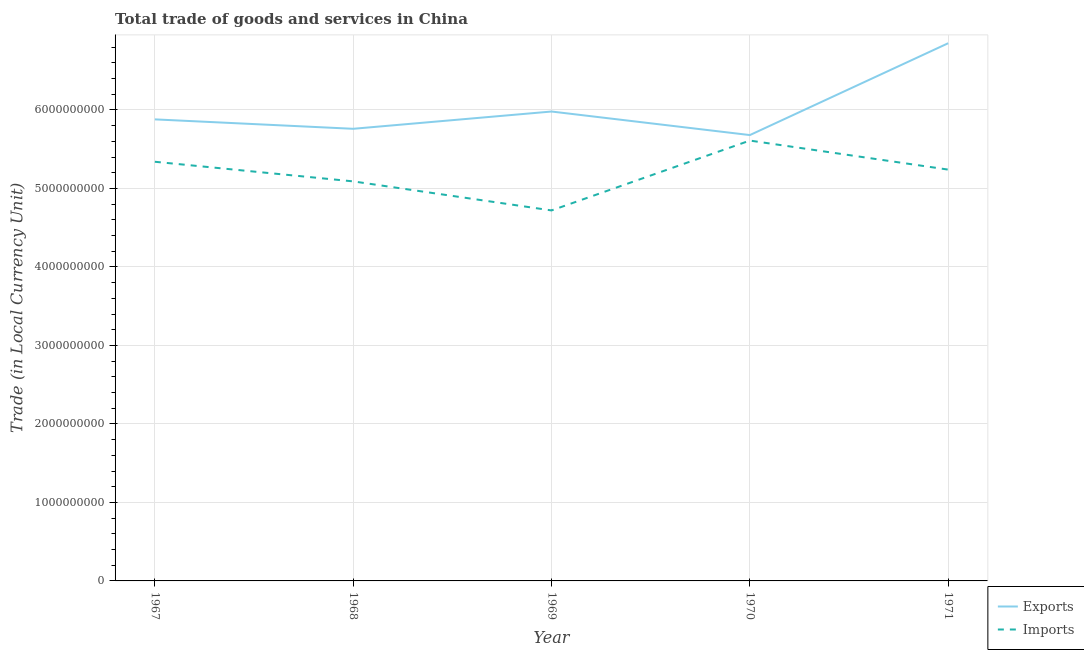How many different coloured lines are there?
Provide a short and direct response. 2. Is the number of lines equal to the number of legend labels?
Provide a short and direct response. Yes. What is the imports of goods and services in 1968?
Offer a terse response. 5.09e+09. Across all years, what is the maximum imports of goods and services?
Ensure brevity in your answer.  5.61e+09. Across all years, what is the minimum export of goods and services?
Keep it short and to the point. 5.68e+09. In which year was the imports of goods and services minimum?
Your answer should be very brief. 1969. What is the total export of goods and services in the graph?
Offer a very short reply. 3.02e+1. What is the difference between the export of goods and services in 1969 and that in 1971?
Keep it short and to the point. -8.70e+08. What is the difference between the imports of goods and services in 1971 and the export of goods and services in 1969?
Offer a very short reply. -7.40e+08. What is the average export of goods and services per year?
Provide a short and direct response. 6.03e+09. In the year 1969, what is the difference between the imports of goods and services and export of goods and services?
Offer a very short reply. -1.26e+09. What is the ratio of the imports of goods and services in 1970 to that in 1971?
Provide a short and direct response. 1.07. Is the export of goods and services in 1967 less than that in 1969?
Your answer should be compact. Yes. What is the difference between the highest and the second highest export of goods and services?
Your response must be concise. 8.70e+08. What is the difference between the highest and the lowest export of goods and services?
Keep it short and to the point. 1.17e+09. Does the export of goods and services monotonically increase over the years?
Ensure brevity in your answer.  No. Is the export of goods and services strictly greater than the imports of goods and services over the years?
Your answer should be compact. Yes. Is the imports of goods and services strictly less than the export of goods and services over the years?
Your answer should be compact. Yes. How many lines are there?
Ensure brevity in your answer.  2. How many years are there in the graph?
Your response must be concise. 5. What is the difference between two consecutive major ticks on the Y-axis?
Provide a short and direct response. 1.00e+09. Are the values on the major ticks of Y-axis written in scientific E-notation?
Offer a very short reply. No. How many legend labels are there?
Offer a terse response. 2. What is the title of the graph?
Your answer should be very brief. Total trade of goods and services in China. Does "Netherlands" appear as one of the legend labels in the graph?
Your answer should be very brief. No. What is the label or title of the Y-axis?
Give a very brief answer. Trade (in Local Currency Unit). What is the Trade (in Local Currency Unit) of Exports in 1967?
Make the answer very short. 5.88e+09. What is the Trade (in Local Currency Unit) in Imports in 1967?
Make the answer very short. 5.34e+09. What is the Trade (in Local Currency Unit) of Exports in 1968?
Provide a short and direct response. 5.76e+09. What is the Trade (in Local Currency Unit) of Imports in 1968?
Keep it short and to the point. 5.09e+09. What is the Trade (in Local Currency Unit) of Exports in 1969?
Your answer should be very brief. 5.98e+09. What is the Trade (in Local Currency Unit) of Imports in 1969?
Provide a short and direct response. 4.72e+09. What is the Trade (in Local Currency Unit) of Exports in 1970?
Provide a short and direct response. 5.68e+09. What is the Trade (in Local Currency Unit) in Imports in 1970?
Give a very brief answer. 5.61e+09. What is the Trade (in Local Currency Unit) of Exports in 1971?
Keep it short and to the point. 6.85e+09. What is the Trade (in Local Currency Unit) in Imports in 1971?
Your response must be concise. 5.24e+09. Across all years, what is the maximum Trade (in Local Currency Unit) in Exports?
Your response must be concise. 6.85e+09. Across all years, what is the maximum Trade (in Local Currency Unit) of Imports?
Make the answer very short. 5.61e+09. Across all years, what is the minimum Trade (in Local Currency Unit) of Exports?
Make the answer very short. 5.68e+09. Across all years, what is the minimum Trade (in Local Currency Unit) in Imports?
Offer a terse response. 4.72e+09. What is the total Trade (in Local Currency Unit) in Exports in the graph?
Keep it short and to the point. 3.02e+1. What is the total Trade (in Local Currency Unit) in Imports in the graph?
Ensure brevity in your answer.  2.60e+1. What is the difference between the Trade (in Local Currency Unit) in Exports in 1967 and that in 1968?
Give a very brief answer. 1.20e+08. What is the difference between the Trade (in Local Currency Unit) of Imports in 1967 and that in 1968?
Provide a succinct answer. 2.50e+08. What is the difference between the Trade (in Local Currency Unit) in Exports in 1967 and that in 1969?
Offer a very short reply. -1.00e+08. What is the difference between the Trade (in Local Currency Unit) in Imports in 1967 and that in 1969?
Your answer should be very brief. 6.20e+08. What is the difference between the Trade (in Local Currency Unit) in Imports in 1967 and that in 1970?
Your answer should be compact. -2.70e+08. What is the difference between the Trade (in Local Currency Unit) in Exports in 1967 and that in 1971?
Your answer should be compact. -9.70e+08. What is the difference between the Trade (in Local Currency Unit) in Exports in 1968 and that in 1969?
Give a very brief answer. -2.20e+08. What is the difference between the Trade (in Local Currency Unit) of Imports in 1968 and that in 1969?
Ensure brevity in your answer.  3.70e+08. What is the difference between the Trade (in Local Currency Unit) in Exports in 1968 and that in 1970?
Ensure brevity in your answer.  8.00e+07. What is the difference between the Trade (in Local Currency Unit) of Imports in 1968 and that in 1970?
Ensure brevity in your answer.  -5.20e+08. What is the difference between the Trade (in Local Currency Unit) in Exports in 1968 and that in 1971?
Your response must be concise. -1.09e+09. What is the difference between the Trade (in Local Currency Unit) of Imports in 1968 and that in 1971?
Give a very brief answer. -1.50e+08. What is the difference between the Trade (in Local Currency Unit) in Exports in 1969 and that in 1970?
Ensure brevity in your answer.  3.00e+08. What is the difference between the Trade (in Local Currency Unit) in Imports in 1969 and that in 1970?
Ensure brevity in your answer.  -8.90e+08. What is the difference between the Trade (in Local Currency Unit) of Exports in 1969 and that in 1971?
Make the answer very short. -8.70e+08. What is the difference between the Trade (in Local Currency Unit) of Imports in 1969 and that in 1971?
Your answer should be compact. -5.20e+08. What is the difference between the Trade (in Local Currency Unit) in Exports in 1970 and that in 1971?
Keep it short and to the point. -1.17e+09. What is the difference between the Trade (in Local Currency Unit) of Imports in 1970 and that in 1971?
Ensure brevity in your answer.  3.70e+08. What is the difference between the Trade (in Local Currency Unit) in Exports in 1967 and the Trade (in Local Currency Unit) in Imports in 1968?
Your answer should be compact. 7.90e+08. What is the difference between the Trade (in Local Currency Unit) of Exports in 1967 and the Trade (in Local Currency Unit) of Imports in 1969?
Your response must be concise. 1.16e+09. What is the difference between the Trade (in Local Currency Unit) of Exports in 1967 and the Trade (in Local Currency Unit) of Imports in 1970?
Ensure brevity in your answer.  2.70e+08. What is the difference between the Trade (in Local Currency Unit) in Exports in 1967 and the Trade (in Local Currency Unit) in Imports in 1971?
Ensure brevity in your answer.  6.40e+08. What is the difference between the Trade (in Local Currency Unit) in Exports in 1968 and the Trade (in Local Currency Unit) in Imports in 1969?
Your answer should be compact. 1.04e+09. What is the difference between the Trade (in Local Currency Unit) of Exports in 1968 and the Trade (in Local Currency Unit) of Imports in 1970?
Your response must be concise. 1.50e+08. What is the difference between the Trade (in Local Currency Unit) in Exports in 1968 and the Trade (in Local Currency Unit) in Imports in 1971?
Your answer should be compact. 5.20e+08. What is the difference between the Trade (in Local Currency Unit) of Exports in 1969 and the Trade (in Local Currency Unit) of Imports in 1970?
Your response must be concise. 3.70e+08. What is the difference between the Trade (in Local Currency Unit) of Exports in 1969 and the Trade (in Local Currency Unit) of Imports in 1971?
Make the answer very short. 7.40e+08. What is the difference between the Trade (in Local Currency Unit) of Exports in 1970 and the Trade (in Local Currency Unit) of Imports in 1971?
Give a very brief answer. 4.40e+08. What is the average Trade (in Local Currency Unit) of Exports per year?
Your answer should be very brief. 6.03e+09. What is the average Trade (in Local Currency Unit) of Imports per year?
Provide a succinct answer. 5.20e+09. In the year 1967, what is the difference between the Trade (in Local Currency Unit) of Exports and Trade (in Local Currency Unit) of Imports?
Provide a short and direct response. 5.40e+08. In the year 1968, what is the difference between the Trade (in Local Currency Unit) of Exports and Trade (in Local Currency Unit) of Imports?
Your response must be concise. 6.70e+08. In the year 1969, what is the difference between the Trade (in Local Currency Unit) in Exports and Trade (in Local Currency Unit) in Imports?
Provide a succinct answer. 1.26e+09. In the year 1970, what is the difference between the Trade (in Local Currency Unit) in Exports and Trade (in Local Currency Unit) in Imports?
Your answer should be very brief. 7.00e+07. In the year 1971, what is the difference between the Trade (in Local Currency Unit) of Exports and Trade (in Local Currency Unit) of Imports?
Provide a short and direct response. 1.61e+09. What is the ratio of the Trade (in Local Currency Unit) in Exports in 1967 to that in 1968?
Offer a very short reply. 1.02. What is the ratio of the Trade (in Local Currency Unit) of Imports in 1967 to that in 1968?
Offer a terse response. 1.05. What is the ratio of the Trade (in Local Currency Unit) in Exports in 1967 to that in 1969?
Offer a terse response. 0.98. What is the ratio of the Trade (in Local Currency Unit) in Imports in 1967 to that in 1969?
Ensure brevity in your answer.  1.13. What is the ratio of the Trade (in Local Currency Unit) in Exports in 1967 to that in 1970?
Offer a terse response. 1.04. What is the ratio of the Trade (in Local Currency Unit) in Imports in 1967 to that in 1970?
Offer a very short reply. 0.95. What is the ratio of the Trade (in Local Currency Unit) of Exports in 1967 to that in 1971?
Make the answer very short. 0.86. What is the ratio of the Trade (in Local Currency Unit) of Imports in 1967 to that in 1971?
Your answer should be very brief. 1.02. What is the ratio of the Trade (in Local Currency Unit) in Exports in 1968 to that in 1969?
Offer a terse response. 0.96. What is the ratio of the Trade (in Local Currency Unit) in Imports in 1968 to that in 1969?
Provide a short and direct response. 1.08. What is the ratio of the Trade (in Local Currency Unit) of Exports in 1968 to that in 1970?
Make the answer very short. 1.01. What is the ratio of the Trade (in Local Currency Unit) in Imports in 1968 to that in 1970?
Provide a short and direct response. 0.91. What is the ratio of the Trade (in Local Currency Unit) of Exports in 1968 to that in 1971?
Offer a terse response. 0.84. What is the ratio of the Trade (in Local Currency Unit) in Imports in 1968 to that in 1971?
Your answer should be very brief. 0.97. What is the ratio of the Trade (in Local Currency Unit) in Exports in 1969 to that in 1970?
Provide a succinct answer. 1.05. What is the ratio of the Trade (in Local Currency Unit) in Imports in 1969 to that in 1970?
Your answer should be compact. 0.84. What is the ratio of the Trade (in Local Currency Unit) of Exports in 1969 to that in 1971?
Give a very brief answer. 0.87. What is the ratio of the Trade (in Local Currency Unit) of Imports in 1969 to that in 1971?
Your answer should be compact. 0.9. What is the ratio of the Trade (in Local Currency Unit) of Exports in 1970 to that in 1971?
Ensure brevity in your answer.  0.83. What is the ratio of the Trade (in Local Currency Unit) in Imports in 1970 to that in 1971?
Offer a very short reply. 1.07. What is the difference between the highest and the second highest Trade (in Local Currency Unit) in Exports?
Your answer should be compact. 8.70e+08. What is the difference between the highest and the second highest Trade (in Local Currency Unit) in Imports?
Provide a succinct answer. 2.70e+08. What is the difference between the highest and the lowest Trade (in Local Currency Unit) of Exports?
Give a very brief answer. 1.17e+09. What is the difference between the highest and the lowest Trade (in Local Currency Unit) in Imports?
Provide a succinct answer. 8.90e+08. 